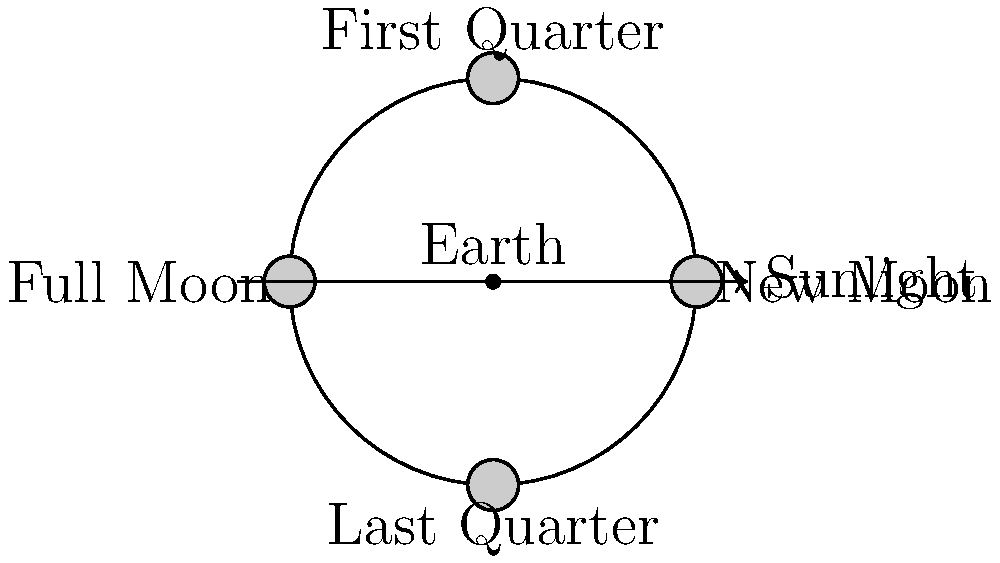As a social activist in Delhi concerned with light pollution, you're educating the public about celestial events. Which phase of the Moon is most visible during late evening hours and why is this knowledge important for planning nighttime awareness campaigns? To answer this question, let's break down the Moon's phases and their visibility:

1. New Moon: The Moon is between the Earth and Sun, with its dark side facing Earth. Not visible at night.

2. Waxing Crescent: A small sliver is visible after sunset, but sets soon after.

3. First Quarter: Half of the Moon's illuminated surface is visible, setting around midnight.

4. Waxing Gibbous: More than half of the Moon is visible, setting after midnight.

5. Full Moon: The entire illuminated face is visible, rising at sunset and setting at sunrise. This is the most visible phase during late evening hours.

6. Waning Gibbous: More than half of the Moon is visible, rising later in the evening.

7. Last Quarter: Half of the Moon is visible, rising around midnight.

8. Waning Crescent: A small sliver is visible before sunrise.

The Full Moon is most visible during late evening hours because it rises around sunset and remains visible throughout the night. This knowledge is important for planning nighttime awareness campaigns because:

a) It provides the most natural illumination, potentially reducing the need for artificial lighting.
b) It can serve as a focal point for celestial observation events, raising awareness about light pollution's impact on stargazing.
c) It allows for scheduling of moonlit walks or outdoor activities to demonstrate the beauty of natural night lighting.
d) It helps in planning events that contrast the brightness of a full moon with the darkness needed to observe other celestial objects, highlighting the importance of dark sky preservation.
Answer: Full Moon 